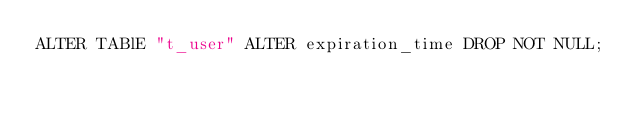Convert code to text. <code><loc_0><loc_0><loc_500><loc_500><_SQL_>ALTER TABlE "t_user" ALTER expiration_time DROP NOT NULL;</code> 